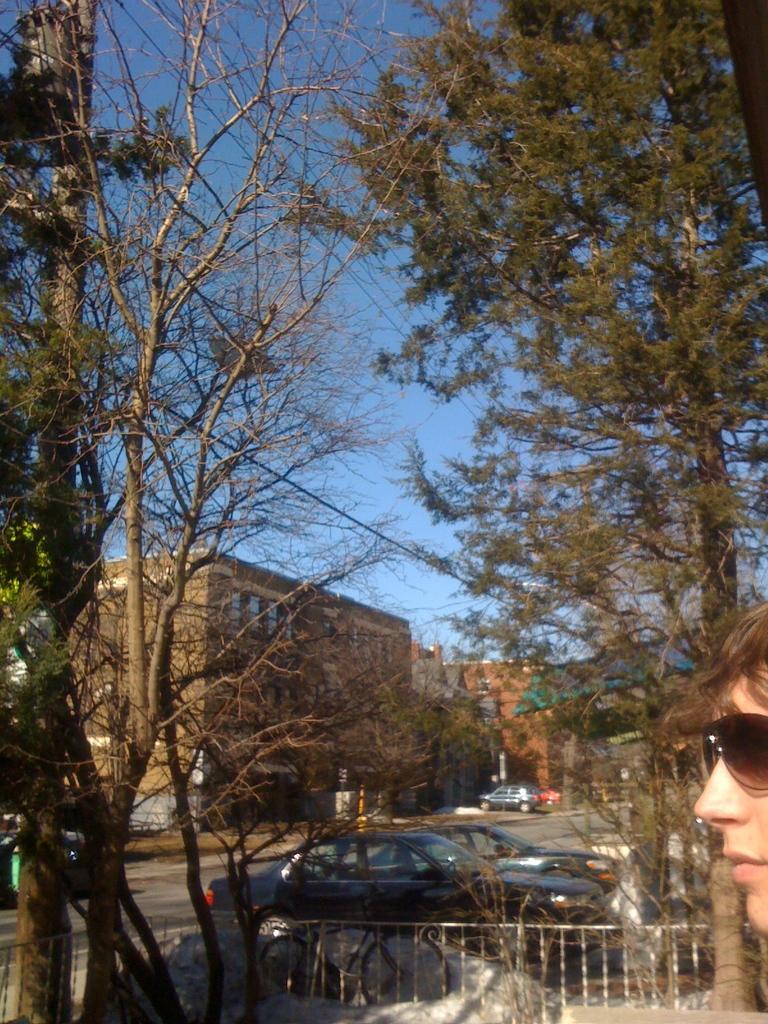Please provide a concise description of this image. In this image I can see vehicle on the road, the right I can see a person face, background I can see trees in green color, building in brown color, sky in blue color. 